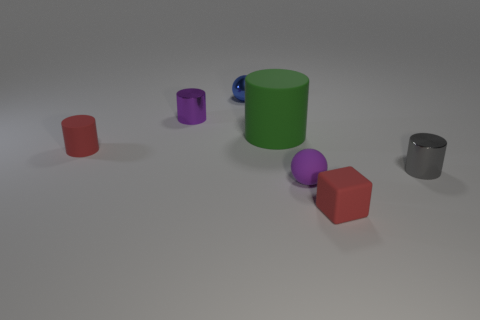Which objects in the image are cylinders? There are two objects in the image that are cylinders. One is purple and the other one is green. 